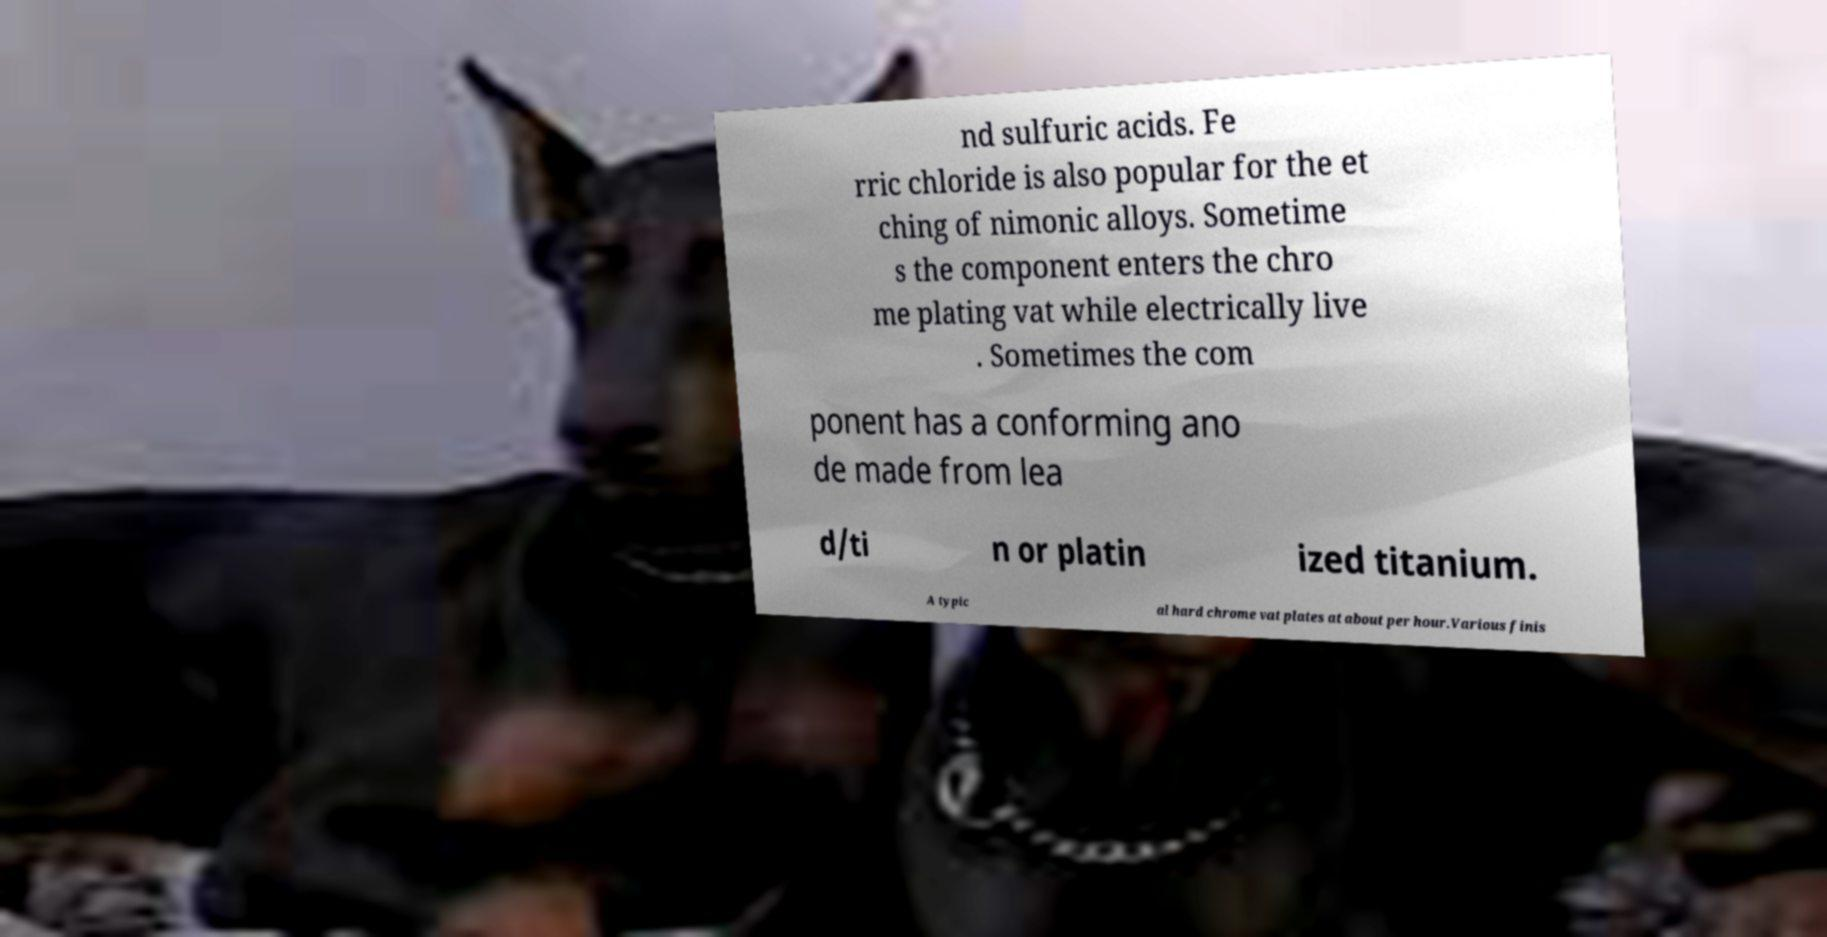Could you assist in decoding the text presented in this image and type it out clearly? nd sulfuric acids. Fe rric chloride is also popular for the et ching of nimonic alloys. Sometime s the component enters the chro me plating vat while electrically live . Sometimes the com ponent has a conforming ano de made from lea d/ti n or platin ized titanium. A typic al hard chrome vat plates at about per hour.Various finis 